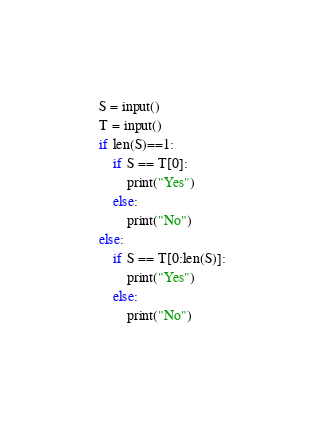Convert code to text. <code><loc_0><loc_0><loc_500><loc_500><_Python_>S = input()
T = input()
if len(S)==1:
    if S == T[0]:
        print("Yes")
    else:
        print("No")
else:
    if S == T[0:len(S)]:
        print("Yes")
    else:
        print("No")</code> 